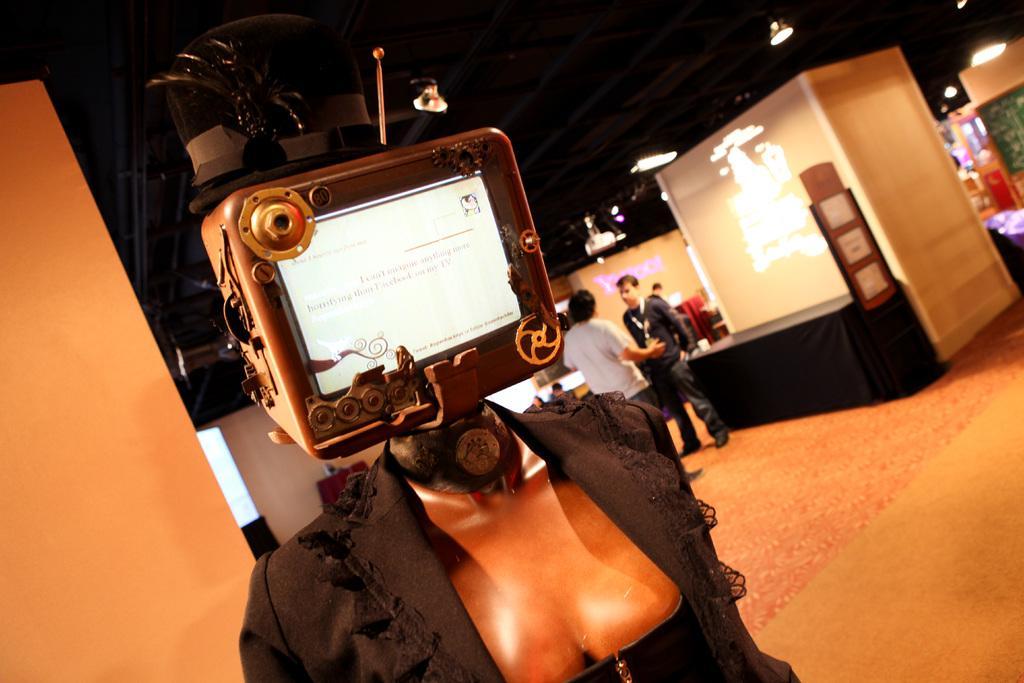Describe this image in one or two sentences. In this image we can see a mannequin with a black color blazer and the LED display board. The background of the image is slightly blurred, where we can see a few people on the floor, boards, pillars, the wall and the ceiling lights. 